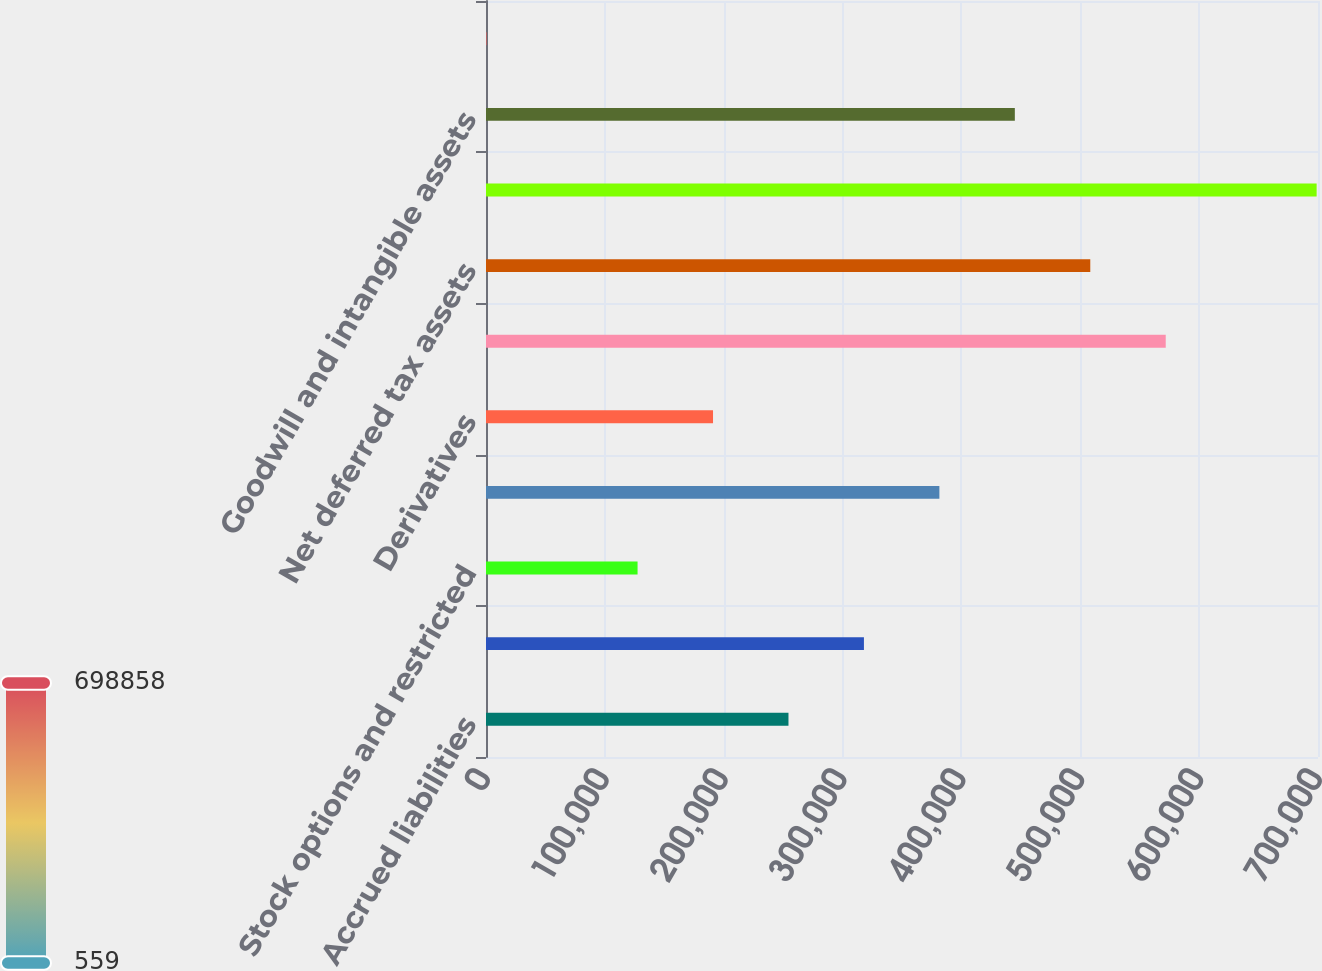Convert chart. <chart><loc_0><loc_0><loc_500><loc_500><bar_chart><fcel>Accrued liabilities<fcel>Employee benefits and<fcel>Stock options and restricted<fcel>Pension and postretirement<fcel>Derivatives<fcel>Gross deferred tax assets<fcel>Net deferred tax assets<fcel>Property plant and equipment<fcel>Goodwill and intangible assets<fcel>Inventories<nl><fcel>254486<fcel>317968<fcel>127522<fcel>381449<fcel>191004<fcel>571894<fcel>508413<fcel>698858<fcel>444931<fcel>559<nl></chart> 